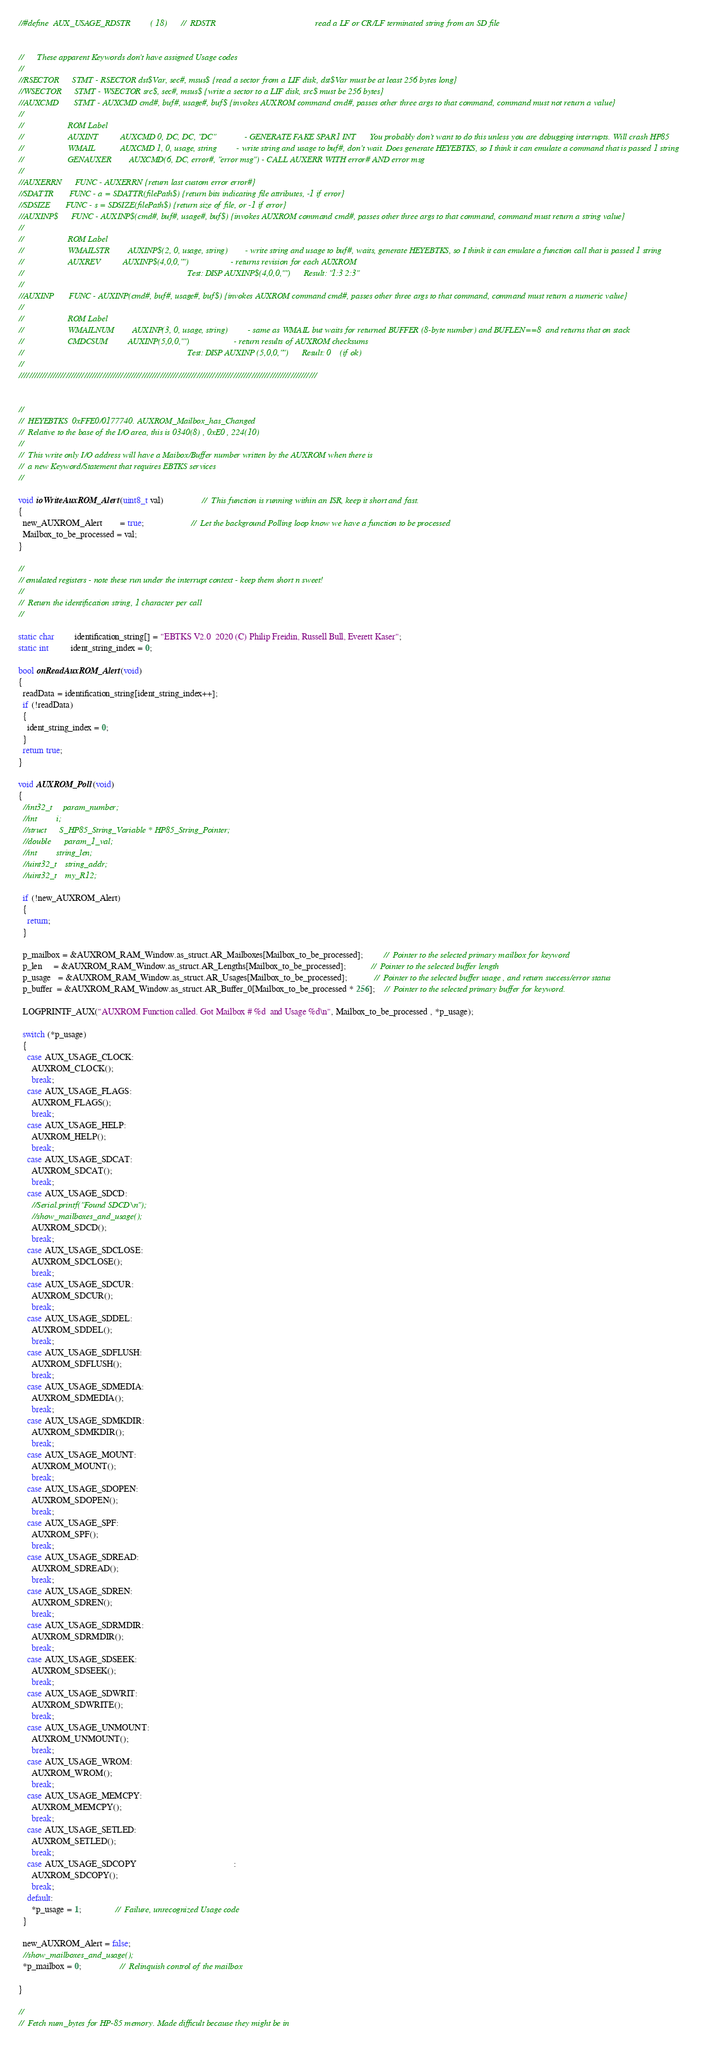<code> <loc_0><loc_0><loc_500><loc_500><_C++_>


//#define  AUX_USAGE_RDSTR         ( 18)      //  RDSTR                                             read a LF or CR/LF terminated string from an SD file


//      These apparent Keywords don't have assigned Usage codes
//
//RSECTOR      STMT - RSECTOR dst$Var, sec#, msus$ {read a sector from a LIF disk, dst$Var must be at least 256 bytes long}
//WSECTOR      STMT - WSECTOR src$, sec#, msus$ {write a sector to a LIF disk, src$ must be 256 bytes}
//AUXCMD       STMT - AUXCMD cmd#, buf#, usage#, buf$ {invokes AUXROM command cmd#, passes other three args to that command, command must not return a value}
//
//                    ROM Label
//                    AUXINT          AUXCMD 0, DC, DC, "DC"             - GENERATE FAKE SPAR1 INT      You probably don't want to do this unless you are debugging interrupts. Will crash HP85
//                    WMAIL           AUXCMD 1, 0, usage, string         - write string and usage to buf#, don't wait. Does generate HEYEBTKS, so I think it can emulate a command that is passed 1 string
//                    GENAUXER        AUXCMD(6, DC, error#, "error msg") - CALL AUXERR WITH error# AND error msg
//
//AUXERRN      FUNC - AUXERRN {return last custom error error#}
//SDATTR       FUNC - a = SDATTR(filePath$) {return bits indicating file attributes, -1 if error}
//SDSIZE       FUNC - s = SDSIZE(filePath$) {return size of file, or -1 if error}
//AUXINP$      FUNC - AUXINP$(cmd#, buf#, usage#, buf$) {invokes AUXROM command cmd#, passes other three args to that command, command must return a string value}
//
//                    ROM Label
//                    WMAILSTR        AUXINP$(2, 0, usage, string)        - write string and usage to buf#, waits, generate HEYEBTKS, so I think it can emulate a function call that is passed 1 string
//                    AUXREV          AUXINP$(4,0,0,"")                   - returns revision for each AUXROM
//                                                                          Test: DISP AUXINP$(4,0,0,"")      Result: "1:3 2:3"
//
//AUXINP       FUNC - AUXINP(cmd#, buf#, usage#, buf$) {invokes AUXROM command cmd#, passes other three args to that command, command must return a numeric value}
//
//                    ROM Label
//                    WMAILNUM        AUXINP(3, 0, usage, string)         - same as WMAIL but waits for returned BUFFER (8-byte number) and BUFLEN==8  and returns that on stack
//                    CMDCSUM         AUXINP(5,0,0,"")                    - return results of AUXROM checksums
//                                                                          Test: DISP AUXINP (5,0,0,"")      Result: 0    (if ok)
//
//////////////////////////////////////////////////////////////////////////////////////////////////////////////////


//
//  HEYEBTKS  0xFFE0/0177740. AUXROM_Mailbox_has_Changed
//  Relative to the base of the I/O area, this is 0340(8) , 0xE0 , 224(10)
//
//  This write only I/O address will have a Maibox/Buffer number written by the AUXROM when there is
//  a new Keyword/Statement that requires EBTKS services
//

void ioWriteAuxROM_Alert(uint8_t val)                 //  This function is running within an ISR, keep it short and fast.
{
  new_AUXROM_Alert        = true;                     //  Let the background Polling loop know we have a function to be processed
  Mailbox_to_be_processed = val;
}

//
// emulated registers - note these run under the interrupt context - keep them short n sweet!
//
//  Return the identification string, 1 character per call
//

static char         identification_string[] = "EBTKS V2.0  2020 (C) Philip Freidin, Russell Bull, Everett Kaser";
static int          ident_string_index = 0;

bool onReadAuxROM_Alert(void)
{
  readData = identification_string[ident_string_index++];
  if (!readData)
  {
    ident_string_index = 0;
  }
  return true;
}

void AUXROM_Poll(void)
{
  //int32_t     param_number;
  //int         i;
  //struct      S_HP85_String_Variable * HP85_String_Pointer;
  //double      param_1_val;
  //int         string_len;
  //uint32_t    string_addr;
  //uint32_t    my_R12;

  if (!new_AUXROM_Alert)
  {
    return;
  }

  p_mailbox = &AUXROM_RAM_Window.as_struct.AR_Mailboxes[Mailbox_to_be_processed];         //  Pointer to the selected primary mailbox for keyword
  p_len     = &AUXROM_RAM_Window.as_struct.AR_Lengths[Mailbox_to_be_processed];           //  Pointer to the selected buffer length
  p_usage   = &AUXROM_RAM_Window.as_struct.AR_Usages[Mailbox_to_be_processed];            //  Pointer to the selected buffer usage , and return success/error status
  p_buffer  = &AUXROM_RAM_Window.as_struct.AR_Buffer_0[Mailbox_to_be_processed * 256];    //  Pointer to the selected primary buffer for keyword.

  LOGPRINTF_AUX("AUXROM Function called. Got Mailbox # %d  and Usage %d\n", Mailbox_to_be_processed , *p_usage);

  switch (*p_usage)
  {
    case AUX_USAGE_CLOCK:
      AUXROM_CLOCK();
      break;
    case AUX_USAGE_FLAGS:
      AUXROM_FLAGS();
      break;
    case AUX_USAGE_HELP:
      AUXROM_HELP();
      break;
    case AUX_USAGE_SDCAT:
      AUXROM_SDCAT();
      break;
    case AUX_USAGE_SDCD:
      //Serial.printf("Found SDCD\n");
      //show_mailboxes_and_usage();
      AUXROM_SDCD();
      break;
    case AUX_USAGE_SDCLOSE:
      AUXROM_SDCLOSE();
      break;
    case AUX_USAGE_SDCUR:
      AUXROM_SDCUR();
      break;
    case AUX_USAGE_SDDEL:
      AUXROM_SDDEL();
      break;
    case AUX_USAGE_SDFLUSH:
      AUXROM_SDFLUSH();
      break;
    case AUX_USAGE_SDMEDIA:
      AUXROM_SDMEDIA();
      break;
    case AUX_USAGE_SDMKDIR:
      AUXROM_SDMKDIR();
      break;
    case AUX_USAGE_MOUNT:
      AUXROM_MOUNT();
      break;
    case AUX_USAGE_SDOPEN:
      AUXROM_SDOPEN();
      break;
    case AUX_USAGE_SPF:
      AUXROM_SPF();
      break;
    case AUX_USAGE_SDREAD:
      AUXROM_SDREAD();
      break;
    case AUX_USAGE_SDREN:
      AUXROM_SDREN();
      break;
    case AUX_USAGE_SDRMDIR:
      AUXROM_SDRMDIR();
      break;
    case AUX_USAGE_SDSEEK:
      AUXROM_SDSEEK();
      break;
    case AUX_USAGE_SDWRIT:
      AUXROM_SDWRITE();
      break;
    case AUX_USAGE_UNMOUNT:
      AUXROM_UNMOUNT();
      break;
    case AUX_USAGE_WROM:
      AUXROM_WROM();
      break;
    case AUX_USAGE_MEMCPY:
      AUXROM_MEMCPY();
      break;
    case AUX_USAGE_SETLED:
      AUXROM_SETLED();
      break;
    case AUX_USAGE_SDCOPY                                            :
      AUXROM_SDCOPY();
      break;
    default:
      *p_usage = 1;               //  Failure, unrecognized Usage code
  }

  new_AUXROM_Alert = false;
  //show_mailboxes_and_usage();
  *p_mailbox = 0;                 //  Relinquish control of the mailbox

}

//
//  Fetch num_bytes for HP-85 memory. Made difficult because they might be in</code> 